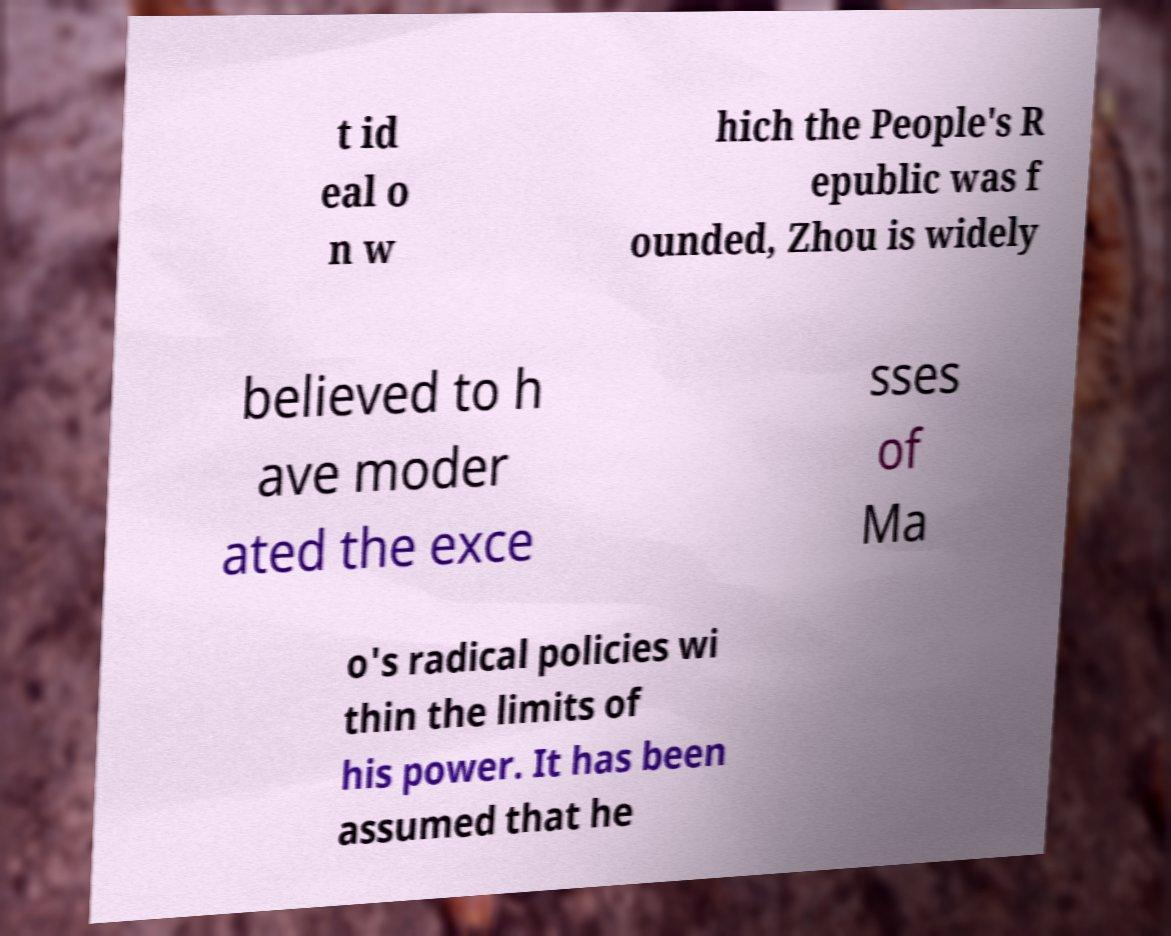Can you accurately transcribe the text from the provided image for me? t id eal o n w hich the People's R epublic was f ounded, Zhou is widely believed to h ave moder ated the exce sses of Ma o's radical policies wi thin the limits of his power. It has been assumed that he 